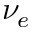Convert formula to latex. <formula><loc_0><loc_0><loc_500><loc_500>\nu _ { e }</formula> 